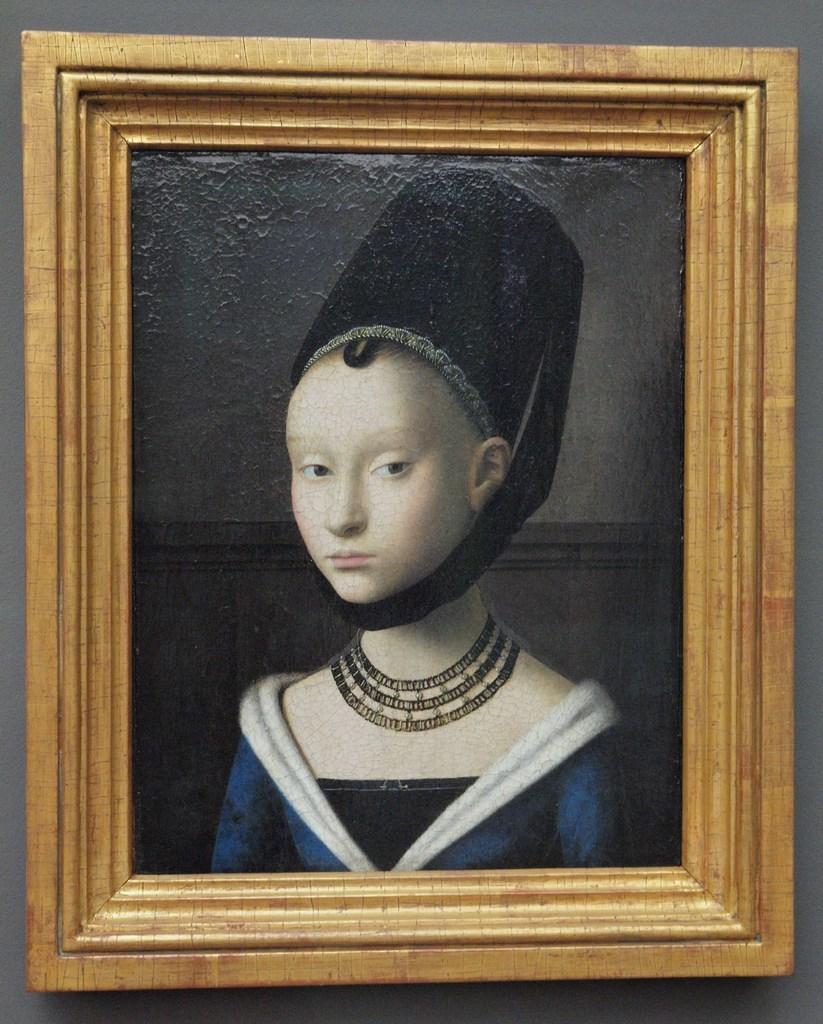Can you describe this image briefly? In the foreground of this image, there is a frame to a grey color wall like structure. 